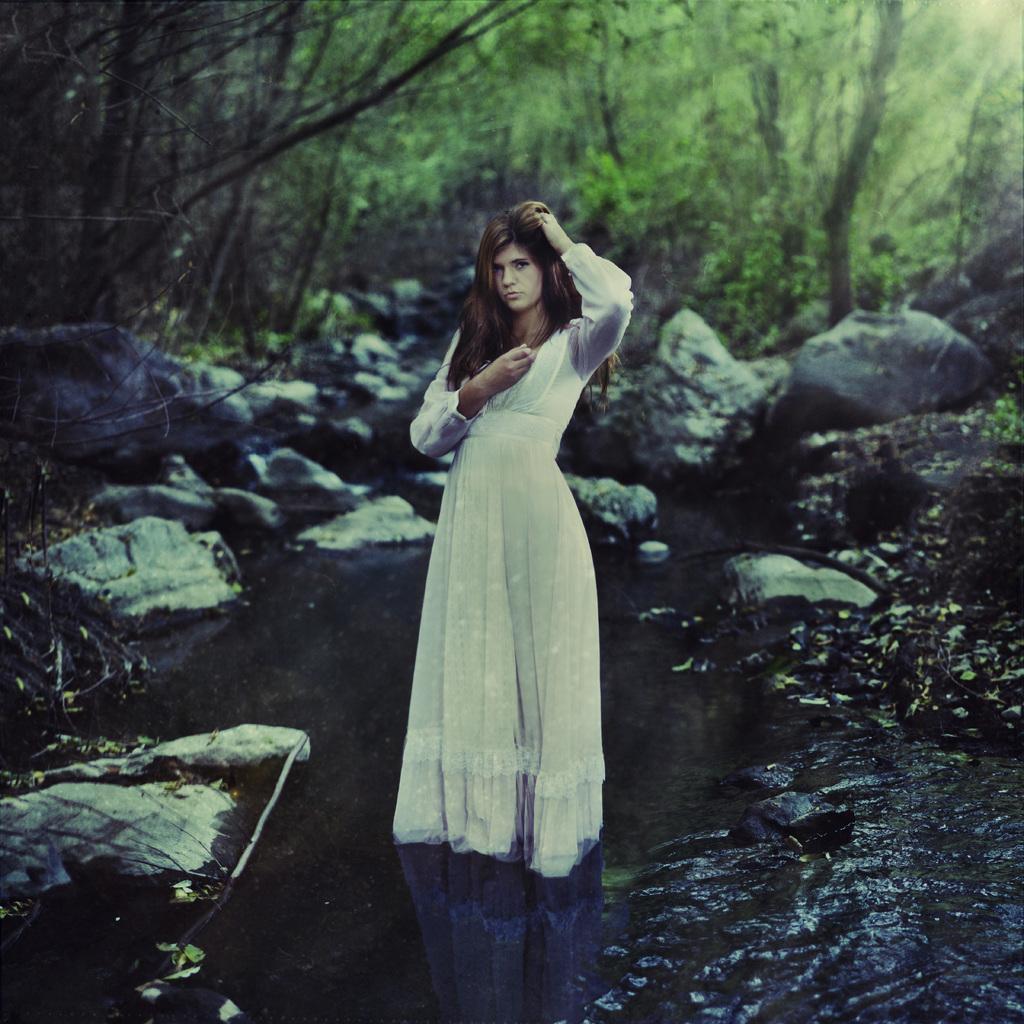In one or two sentences, can you explain what this image depicts? In this image I can see a woman is standing and I can see she is wearing white colour dress. I can also see water, number of stones, grass and number of trees. 